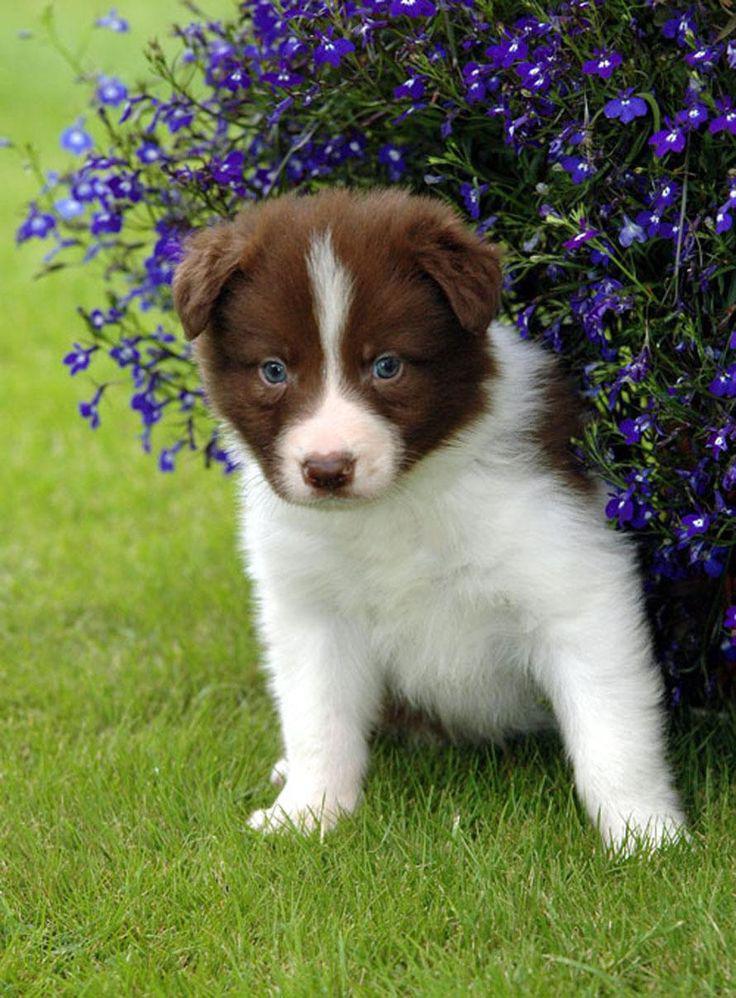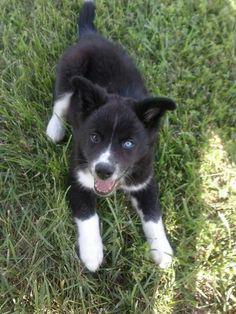The first image is the image on the left, the second image is the image on the right. Examine the images to the left and right. Is the description "An image shows a dog reclining on the grass with its head cocked at a sharp angle." accurate? Answer yes or no. No. The first image is the image on the left, the second image is the image on the right. For the images shown, is this caption "The dog in one of the images has its head tilted to the side." true? Answer yes or no. No. 